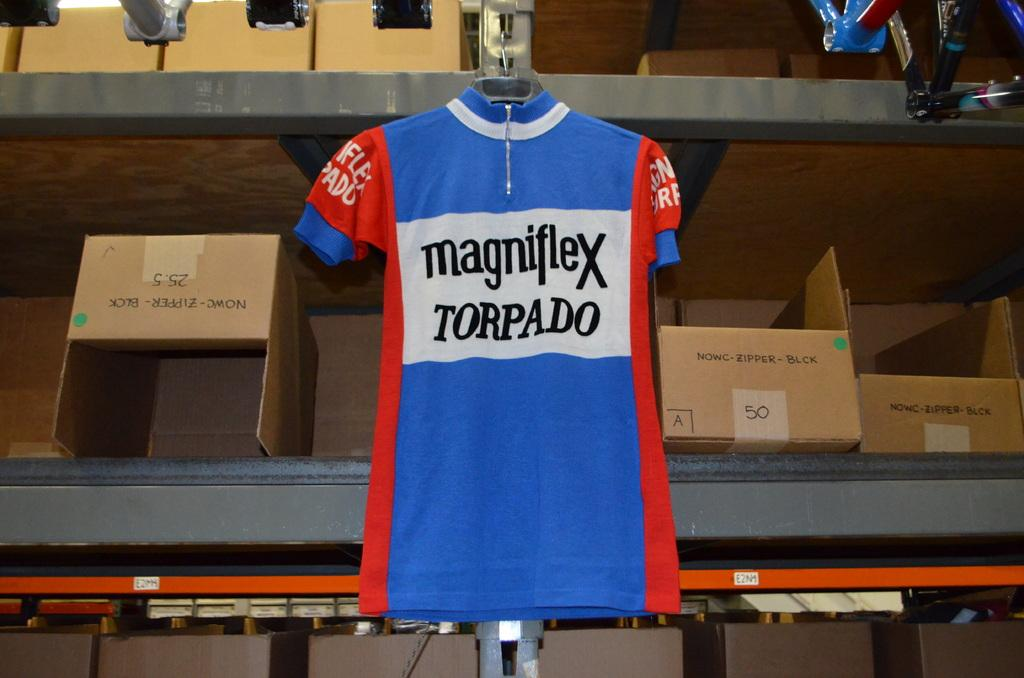<image>
Create a compact narrative representing the image presented. A blue and red jersey has "magniflex torpado" printed on it. 